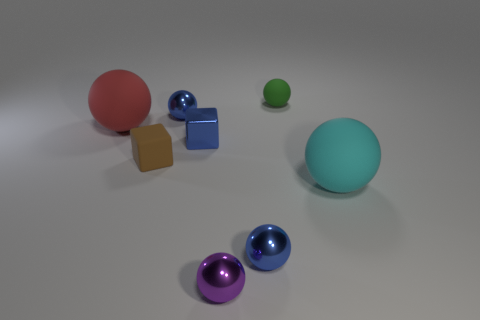There is a big rubber sphere to the right of the small thing that is on the right side of the blue sphere that is right of the small purple ball; what color is it?
Your response must be concise. Cyan. Are there fewer blue metal things that are in front of the blue block than green matte spheres in front of the cyan rubber object?
Give a very brief answer. No. Does the red object have the same shape as the green matte thing?
Ensure brevity in your answer.  Yes. How many cyan balls are the same size as the red rubber sphere?
Give a very brief answer. 1. Are there fewer green spheres that are on the left side of the red matte sphere than big cyan metal things?
Give a very brief answer. No. What is the size of the rubber ball in front of the big matte object that is on the left side of the brown matte block?
Offer a terse response. Large. How many things are either yellow metallic objects or brown cubes?
Offer a terse response. 1. Are there any things that have the same color as the tiny metallic block?
Make the answer very short. Yes. Is the number of small green matte things less than the number of large purple metallic blocks?
Offer a terse response. No. How many things are either large cyan rubber spheres or small metal things that are behind the purple object?
Provide a succinct answer. 4. 